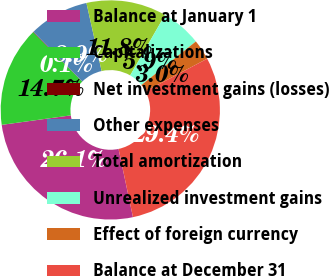Convert chart. <chart><loc_0><loc_0><loc_500><loc_500><pie_chart><fcel>Balance at January 1<fcel>Capitalizations<fcel>Net investment gains (losses)<fcel>Other expenses<fcel>Total amortization<fcel>Unrealized investment gains<fcel>Effect of foreign currency<fcel>Balance at December 31<nl><fcel>26.14%<fcel>14.74%<fcel>0.07%<fcel>8.87%<fcel>11.81%<fcel>5.94%<fcel>3.0%<fcel>29.42%<nl></chart> 